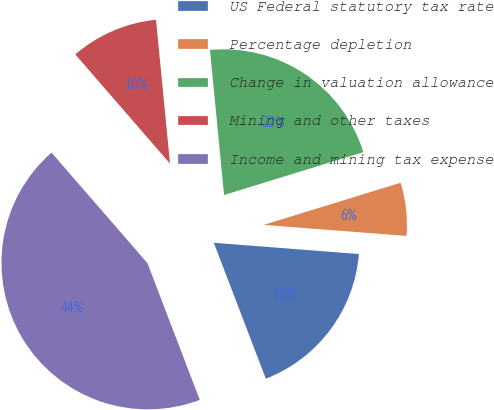Convert chart to OTSL. <chart><loc_0><loc_0><loc_500><loc_500><pie_chart><fcel>US Federal statutory tax rate<fcel>Percentage depletion<fcel>Change in valuation allowance<fcel>Mining and other taxes<fcel>Income and mining tax expense<nl><fcel>17.95%<fcel>5.98%<fcel>21.79%<fcel>9.83%<fcel>44.44%<nl></chart> 